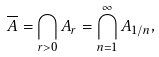Convert formula to latex. <formula><loc_0><loc_0><loc_500><loc_500>\overline { A } = \bigcap _ { r > 0 } A _ { r } = \bigcap _ { n = 1 } ^ { \infty } A _ { 1 / n } ,</formula> 